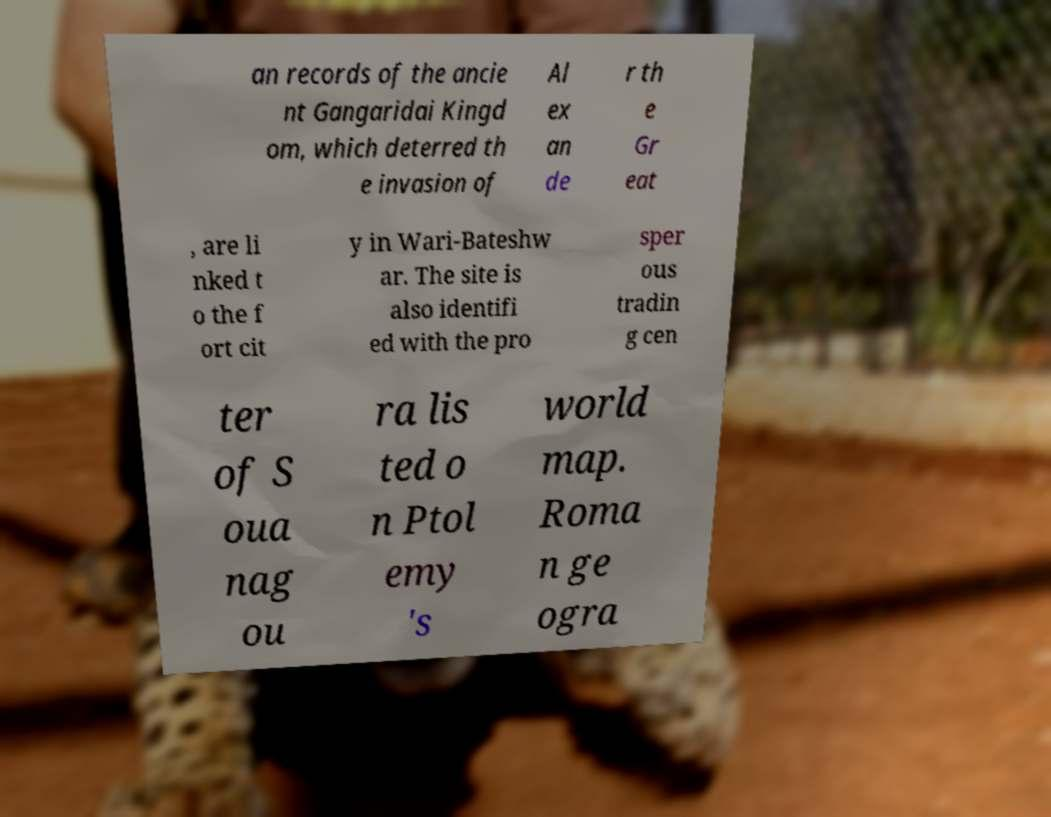I need the written content from this picture converted into text. Can you do that? an records of the ancie nt Gangaridai Kingd om, which deterred th e invasion of Al ex an de r th e Gr eat , are li nked t o the f ort cit y in Wari-Bateshw ar. The site is also identifi ed with the pro sper ous tradin g cen ter of S oua nag ou ra lis ted o n Ptol emy 's world map. Roma n ge ogra 